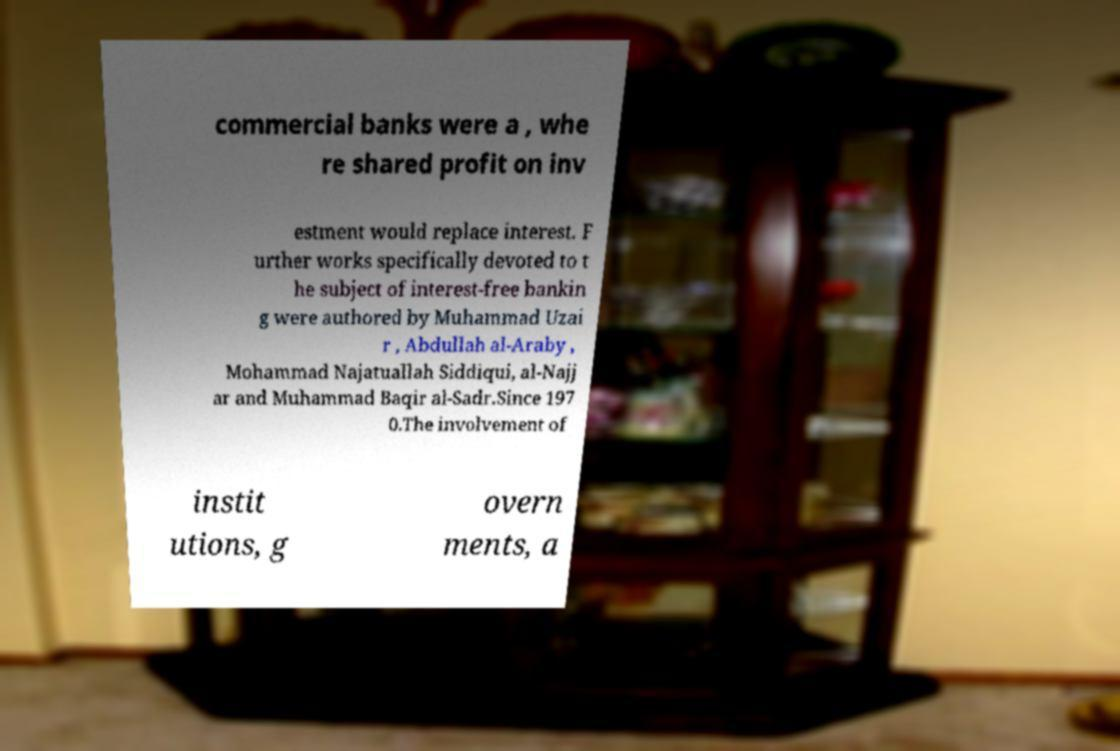Please read and relay the text visible in this image. What does it say? commercial banks were a , whe re shared profit on inv estment would replace interest. F urther works specifically devoted to t he subject of interest-free bankin g were authored by Muhammad Uzai r , Abdullah al-Araby , Mohammad Najatuallah Siddiqui, al-Najj ar and Muhammad Baqir al-Sadr.Since 197 0.The involvement of instit utions, g overn ments, a 